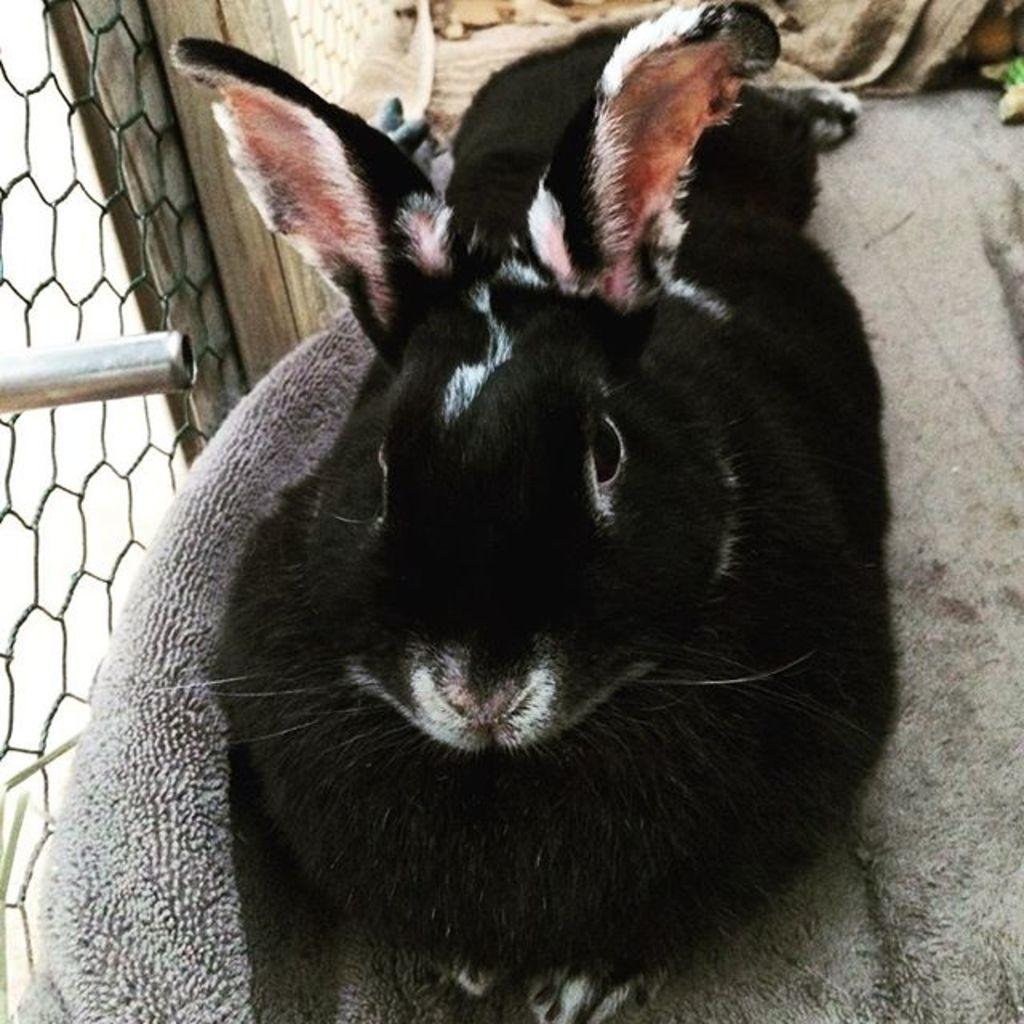What animal can be seen on the ground in the image? There is a rabbit on the ground in the image. What object is located beside the rabbit? There is a cloth beside the rabbit. What type of structure is on the left side of the image? There is a fence on the left side of the image. What is near the fence in the image? There is a pole near the fence in the image. What word is written on the rabbit's ear in the image? There are no words written on the rabbit's ear in the image; it is a rabbit without any text. 